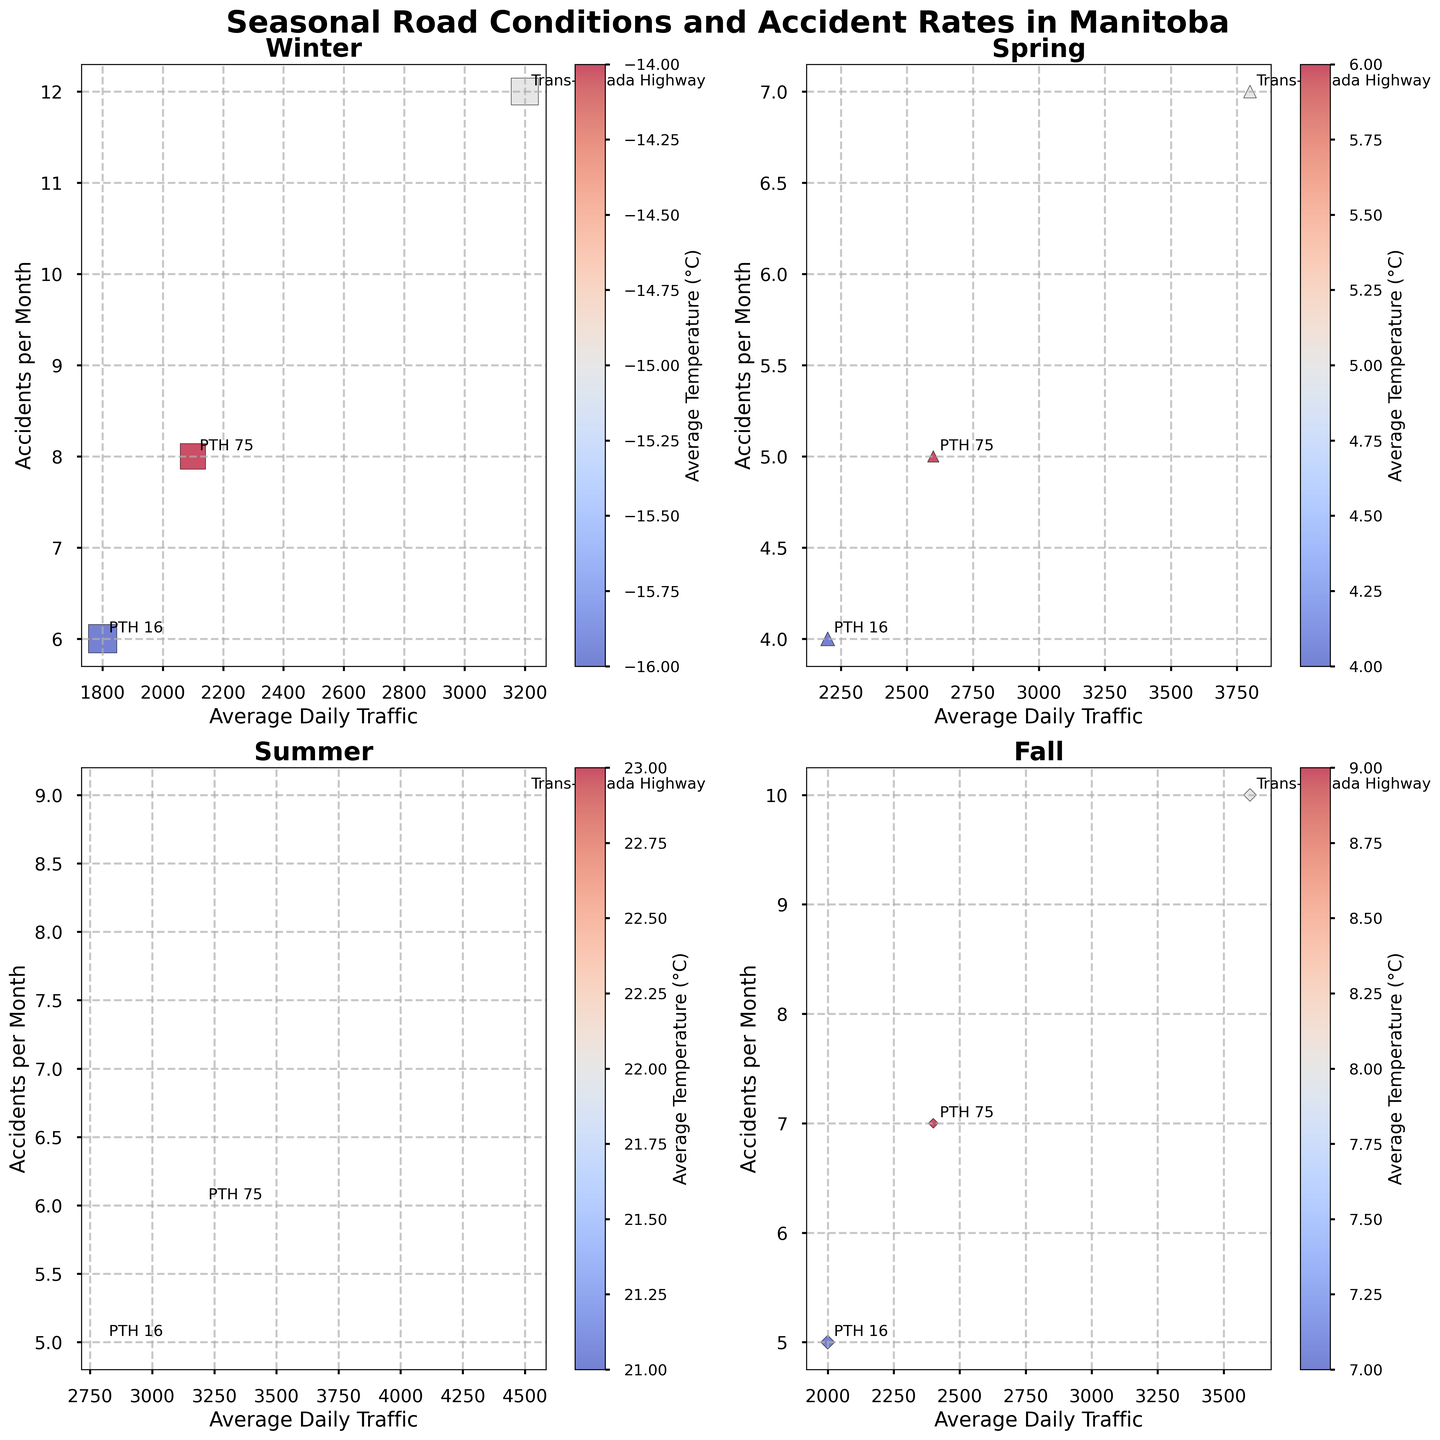What is the average number of accidents per month in winter on the Trans-Canada Highway? From the winter subplot, locate the point for the Trans-Canada Highway and note the "Accidents per Month" value.
Answer: 12 Which season has the highest average daily traffic on PTH 75? Check all the subplots for the points labeled "PTH 75" and compare the "Average Daily Traffic" values. The summer season has the highest average daily traffic of 3200.
Answer: Summer What is the difference in the number of accidents between winter and summer on PTH 16? Find the "Accidents per Month" values for PTH 16 in both the winter and summer subplots. Winter has 6 accidents and the summer has 5 accidents. The difference is 6 - 5.
Answer: 1 Which season has the highest average daily traffic overall? Compare the "Average Daily Traffic" values across all seasons and highways. The highest value is found in summer with 4500 on the Trans-Canada Highway.
Answer: Summer Is there a relationship between snowfall and the number of accidents in winter? Look at the winter subplot and examine if there is a correlation between the size of the markers (representing snowfall) and the number of accidents. Larger markers (more snowfall) tend to align with more accidents.
Answer: Yes, more snowfall seems to correlate with more accidents Which season has the highest accident rate on any highway? Compare the "Accidents per Month" values across all subplots for all highways. The winter subplot shows the highest accident rate on the Trans-Canada Highway with 12 accidents.
Answer: Winter How does the number of accidents in fall on the Trans-Canada Highway compare to the number in spring? Check the fall subplot for the Trans-Canada Highway's accident value (10) and compare it to the spring subplot (7).
Answer: Fall has more accidents than spring What is the average temperature range across all seasons? Look at the color bars of each subplot representing average temperature. The temperatures range from -16°C in winter to 23°C in summer. The range is 23 - (-16) = 39°C.
Answer: 39°C Which highway has a consistent accident rate across all seasons? Observe the "Accidents per Month" values for each highway across the subplots. PTH 16 has values 6, 4, 5, 5 which are relatively consistent.
Answer: PTH 16 Does higher traffic generally result in more accidents according to the plot? Examine the subplots to see if higher "Average Daily Traffic" points consistently align with more "Accidents per Month". There is a general trend that higher traffic corresponds with more accidents.
Answer: Yes 